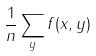<formula> <loc_0><loc_0><loc_500><loc_500>\frac { 1 } { n } \sum _ { y } f ( x , y )</formula> 